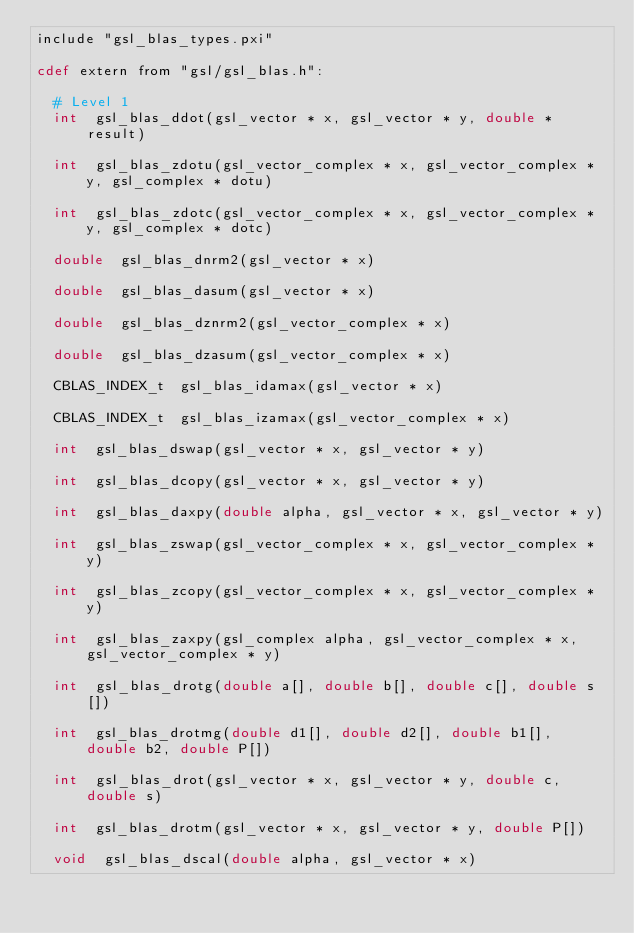<code> <loc_0><loc_0><loc_500><loc_500><_Cython_>include "gsl_blas_types.pxi"

cdef extern from "gsl/gsl_blas.h":

  # Level 1
  int  gsl_blas_ddot(gsl_vector * x, gsl_vector * y, double * result)

  int  gsl_blas_zdotu(gsl_vector_complex * x, gsl_vector_complex * y, gsl_complex * dotu)

  int  gsl_blas_zdotc(gsl_vector_complex * x, gsl_vector_complex * y, gsl_complex * dotc)

  double  gsl_blas_dnrm2(gsl_vector * x)

  double  gsl_blas_dasum(gsl_vector * x)

  double  gsl_blas_dznrm2(gsl_vector_complex * x)

  double  gsl_blas_dzasum(gsl_vector_complex * x)

  CBLAS_INDEX_t  gsl_blas_idamax(gsl_vector * x)

  CBLAS_INDEX_t  gsl_blas_izamax(gsl_vector_complex * x)

  int  gsl_blas_dswap(gsl_vector * x, gsl_vector * y)

  int  gsl_blas_dcopy(gsl_vector * x, gsl_vector * y)

  int  gsl_blas_daxpy(double alpha, gsl_vector * x, gsl_vector * y)

  int  gsl_blas_zswap(gsl_vector_complex * x, gsl_vector_complex * y)

  int  gsl_blas_zcopy(gsl_vector_complex * x, gsl_vector_complex * y)

  int  gsl_blas_zaxpy(gsl_complex alpha, gsl_vector_complex * x, gsl_vector_complex * y)

  int  gsl_blas_drotg(double a[], double b[], double c[], double s[])

  int  gsl_blas_drotmg(double d1[], double d2[], double b1[], double b2, double P[])

  int  gsl_blas_drot(gsl_vector * x, gsl_vector * y, double c, double s)

  int  gsl_blas_drotm(gsl_vector * x, gsl_vector * y, double P[])

  void  gsl_blas_dscal(double alpha, gsl_vector * x)
</code> 